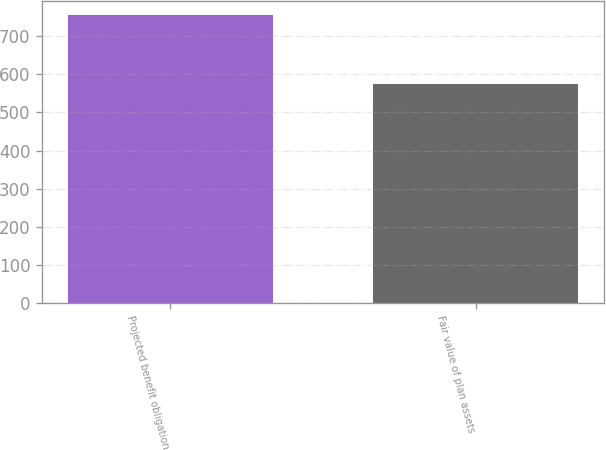Convert chart. <chart><loc_0><loc_0><loc_500><loc_500><bar_chart><fcel>Projected benefit obligation<fcel>Fair value of plan assets<nl><fcel>755<fcel>574<nl></chart> 